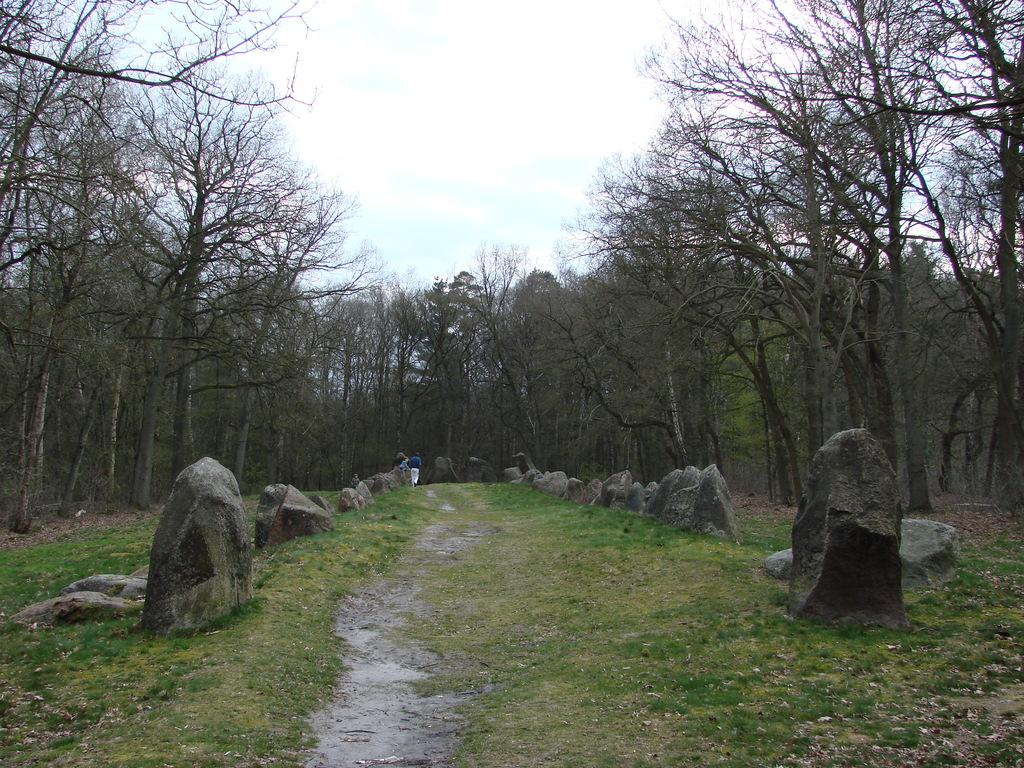Who or what can be seen in the image? There are people in the image. What is on the ground in the image? There are rocks on the ground in the image. What can be seen in the distance in the image? There are trees in the background of the image. What is visible at the top of the image? The sky is visible at the top of the image. What type of canvas is being used by the manager in the image? There is no manager or canvas present in the image. 